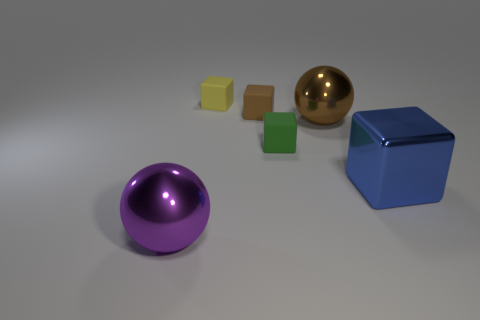How many cylinders are either purple metallic things or blue metallic things?
Your response must be concise. 0. The tiny brown rubber thing is what shape?
Make the answer very short. Cube. Are there any matte blocks to the left of the green rubber cube?
Ensure brevity in your answer.  Yes. Do the large cube and the tiny block in front of the brown shiny ball have the same material?
Your answer should be compact. No. Is the shape of the yellow rubber object behind the green cube the same as  the green object?
Keep it short and to the point. Yes. What number of large blue things have the same material as the yellow object?
Give a very brief answer. 0. How many objects are either blocks in front of the yellow cube or blue metal blocks?
Your response must be concise. 3. What is the size of the blue shiny object?
Provide a short and direct response. Large. What is the material of the tiny object that is in front of the big metallic object that is behind the small green matte object?
Give a very brief answer. Rubber. There is a purple sphere that is left of the metallic cube; is it the same size as the yellow thing?
Your response must be concise. No. 